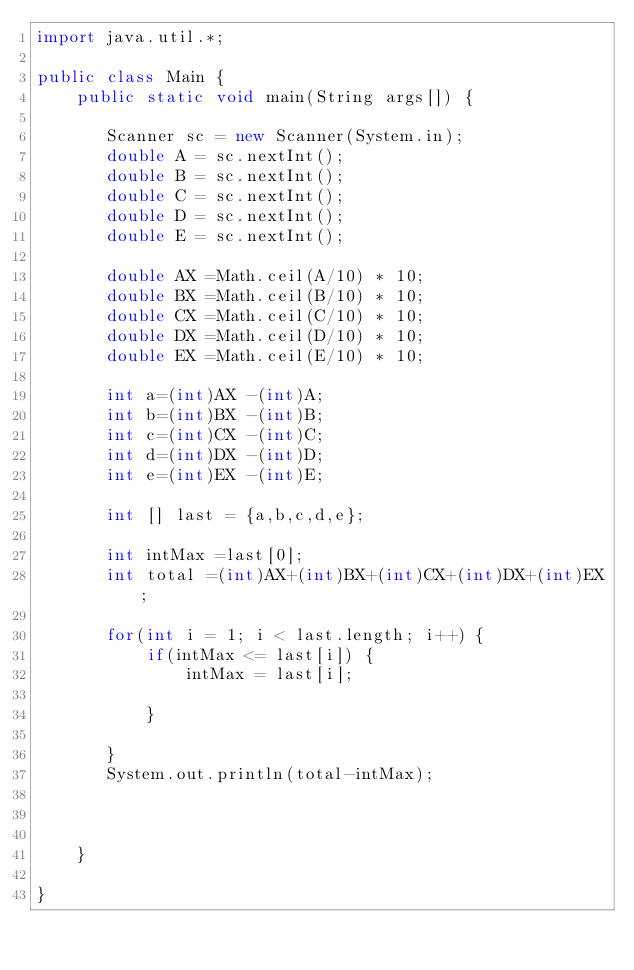Convert code to text. <code><loc_0><loc_0><loc_500><loc_500><_Java_>import java.util.*;
 
public class Main {
    public static void main(String args[]) {
        
       Scanner sc = new Scanner(System.in);
       double A = sc.nextInt();
       double B = sc.nextInt();
       double C = sc.nextInt();
       double D = sc.nextInt();
       double E = sc.nextInt();
       
       double AX =Math.ceil(A/10) * 10;
       double BX =Math.ceil(B/10) * 10;
       double CX =Math.ceil(C/10) * 10;
       double DX =Math.ceil(D/10) * 10;
       double EX =Math.ceil(E/10) * 10;
       
       int a=(int)AX -(int)A;
       int b=(int)BX -(int)B;
       int c=(int)CX -(int)C;
       int d=(int)DX -(int)D;
       int e=(int)EX -(int)E;
       
       int [] last = {a,b,c,d,e};
       
       int intMax =last[0];
       int total =(int)AX+(int)BX+(int)CX+(int)DX+(int)EX;
       
       for(int i = 1; i < last.length; i++) {
           if(intMax <= last[i]) {
               intMax = last[i];
               
           }
           
       }
       System.out.println(total-intMax);
       
    
        
    }
    
}</code> 